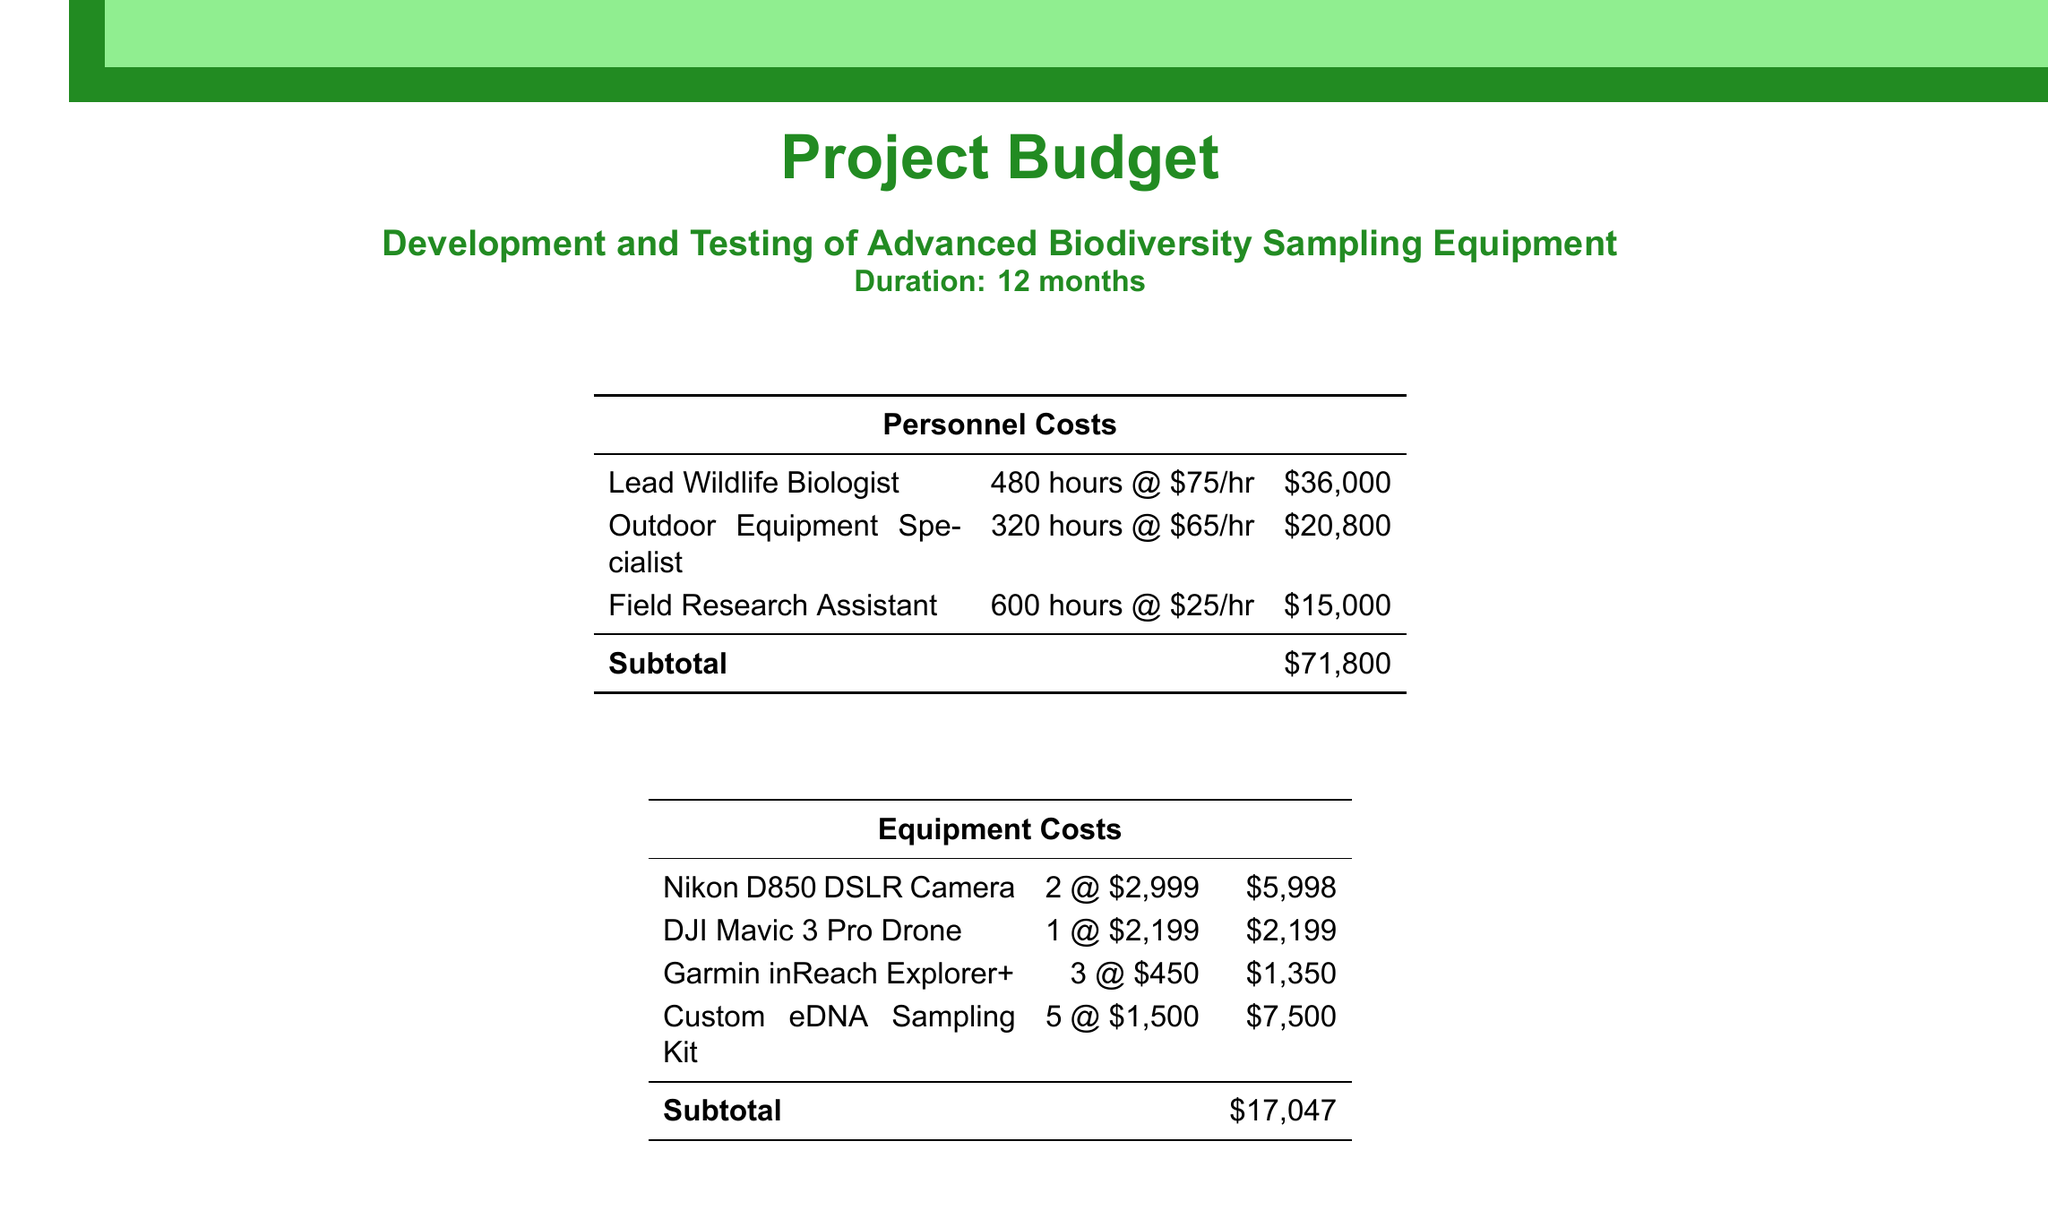What is the total budget? The total budget is calculated by adding the subtotal and the contingency, which is $103,947 + $10,395 = $114,342.
Answer: $114,342 How many hours is the Lead Wildlife Biologist contracted for? The Lead Wildlife Biologist is contracted for 480 hours according to the personnel costs table.
Answer: 480 hours What is the cost of the Custom eDNA Sampling Kit? The Custom eDNA Sampling Kit costs $1,500 each, with a total for 5 kits being $7,500 as shown in the equipment costs table.
Answer: $7,500 What is the subtotal for Other Expenses? The subtotal for Other Expenses is the total of all listed other expenses, which amounts to $15,100.
Answer: $15,100 Who is the Outdoor Equipment Specialist? The Outdoor Equipment Specialist is listed in the personnel costs table as one of the roles needed for the project.
Answer: Outdoor Equipment Specialist How much is allocated for field site visits? The cost allocated for field site visits in the document is $7,200, calculated by 6 trips at $1,200 each.
Answer: $7,200 What percentage is the contingency based on the subtotal? The contingency is stated as 10% of the subtotal in the document, which is a common practice in budgeting for unforeseen costs.
Answer: 10% What is the duration of the project? The project's duration is stated at the beginning of the document as 12 months.
Answer: 12 months How many DSLR cameras are included in the equipment costs? The document states that 2 Nikon D850 DSLR Cameras are included in the equipment costs.
Answer: 2 